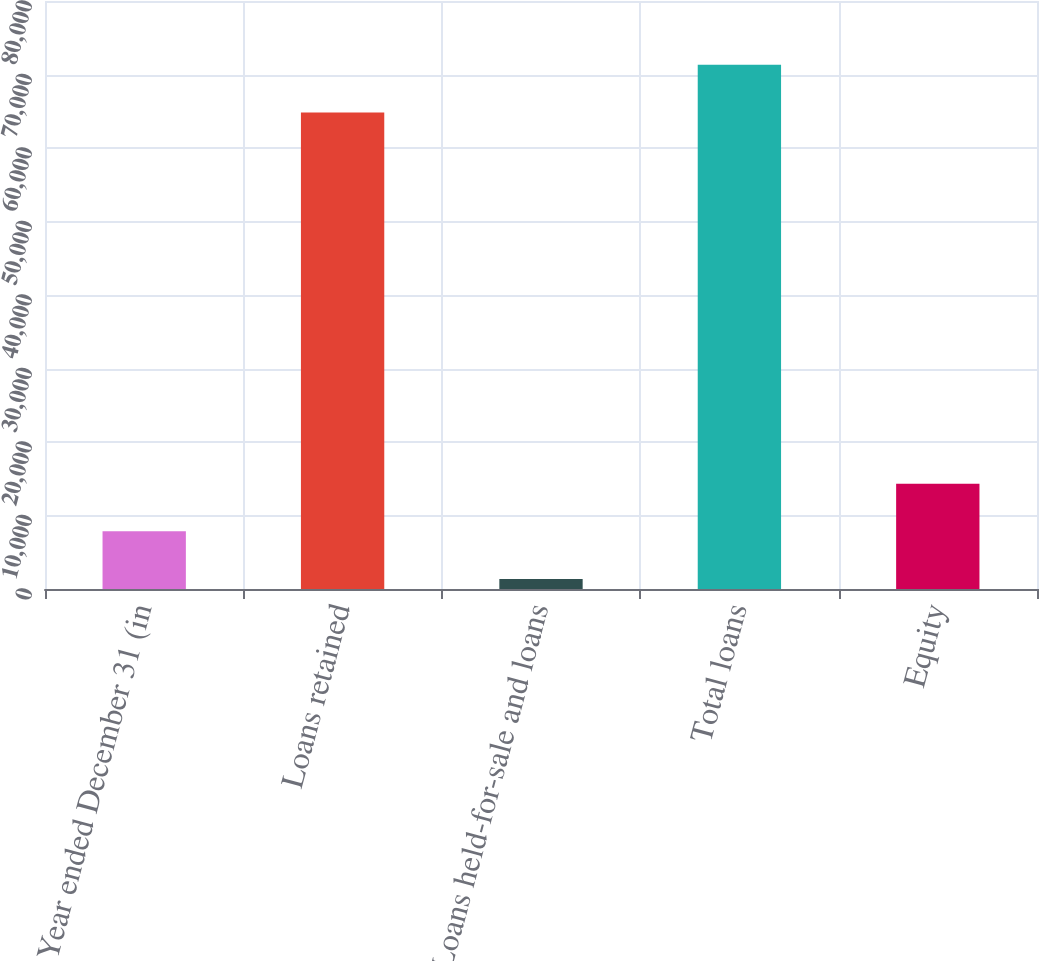Convert chart to OTSL. <chart><loc_0><loc_0><loc_500><loc_500><bar_chart><fcel>Year ended December 31 (in<fcel>Loans retained<fcel>Loans held-for-sale and loans<fcel>Total loans<fcel>Equity<nl><fcel>7849.5<fcel>64835<fcel>1366<fcel>71318.5<fcel>14333<nl></chart> 